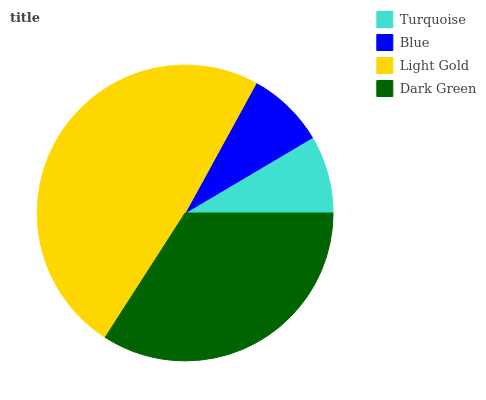Is Turquoise the minimum?
Answer yes or no. Yes. Is Light Gold the maximum?
Answer yes or no. Yes. Is Blue the minimum?
Answer yes or no. No. Is Blue the maximum?
Answer yes or no. No. Is Blue greater than Turquoise?
Answer yes or no. Yes. Is Turquoise less than Blue?
Answer yes or no. Yes. Is Turquoise greater than Blue?
Answer yes or no. No. Is Blue less than Turquoise?
Answer yes or no. No. Is Dark Green the high median?
Answer yes or no. Yes. Is Blue the low median?
Answer yes or no. Yes. Is Light Gold the high median?
Answer yes or no. No. Is Dark Green the low median?
Answer yes or no. No. 